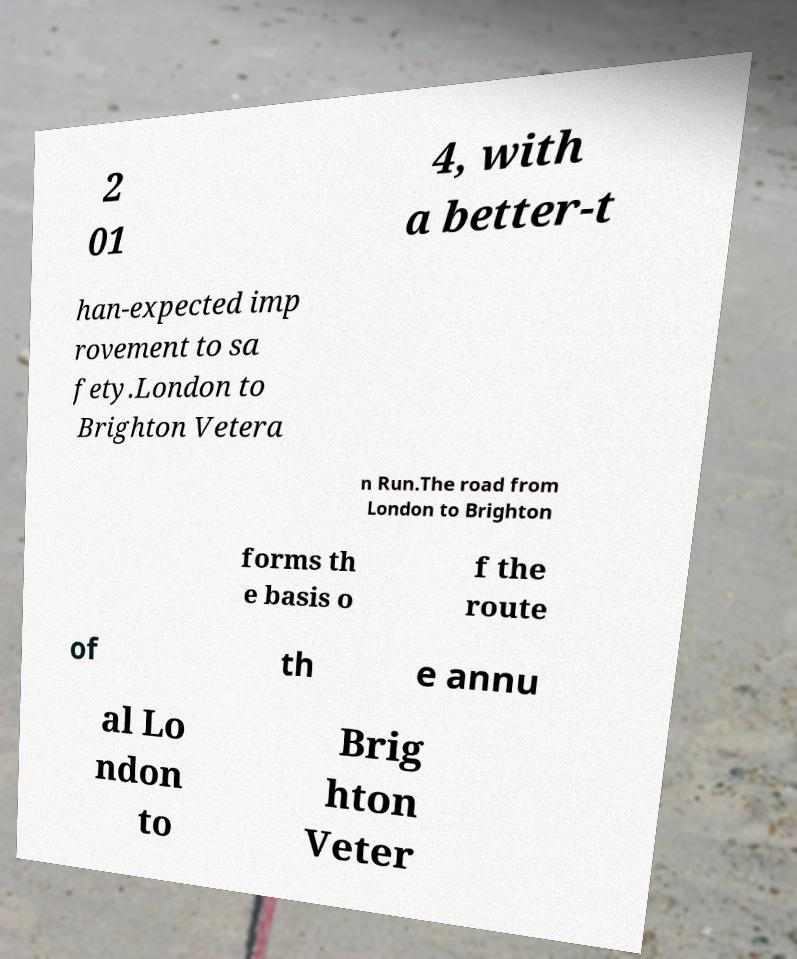Could you extract and type out the text from this image? 2 01 4, with a better-t han-expected imp rovement to sa fety.London to Brighton Vetera n Run.The road from London to Brighton forms th e basis o f the route of th e annu al Lo ndon to Brig hton Veter 